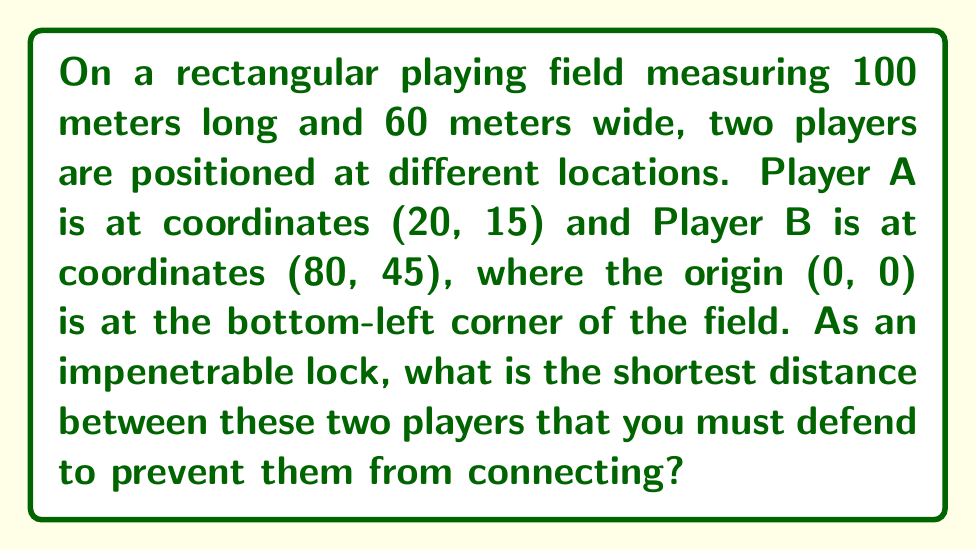Can you solve this math problem? To find the shortest distance between two points on a plane, we can use the distance formula derived from the Pythagorean theorem:

$$d = \sqrt{(x_2 - x_1)^2 + (y_2 - y_1)^2}$$

Where $(x_1, y_1)$ are the coordinates of Player A and $(x_2, y_2)$ are the coordinates of Player B.

Step 1: Identify the coordinates
Player A: $(x_1, y_1) = (20, 15)$
Player B: $(x_2, y_2) = (80, 45)$

Step 2: Plug the coordinates into the distance formula
$$d = \sqrt{(80 - 20)^2 + (45 - 15)^2}$$

Step 3: Simplify the expressions inside the parentheses
$$d = \sqrt{60^2 + 30^2}$$

Step 4: Calculate the squares
$$d = \sqrt{3600 + 900}$$

Step 5: Add the values under the square root
$$d = \sqrt{4500}$$

Step 6: Simplify the square root
$$d = 10\sqrt{45} \approx 67.08$$

Therefore, the shortest distance between the two players is $10\sqrt{45}$ meters or approximately 67.08 meters.

[asy]
size(200);
draw((0,0)--(100,0)--(100,60)--(0,60)--cycle);
dot((20,15),red);
dot((80,45),blue);
draw((20,15)--(80,45),green);
label("A",(20,15),SW,red);
label("B",(80,45),NE,blue);
label("(0,0)",(0,0),SW);
label("(100,60)",(100,60),NE);
[/asy]
Answer: $10\sqrt{45}$ meters 